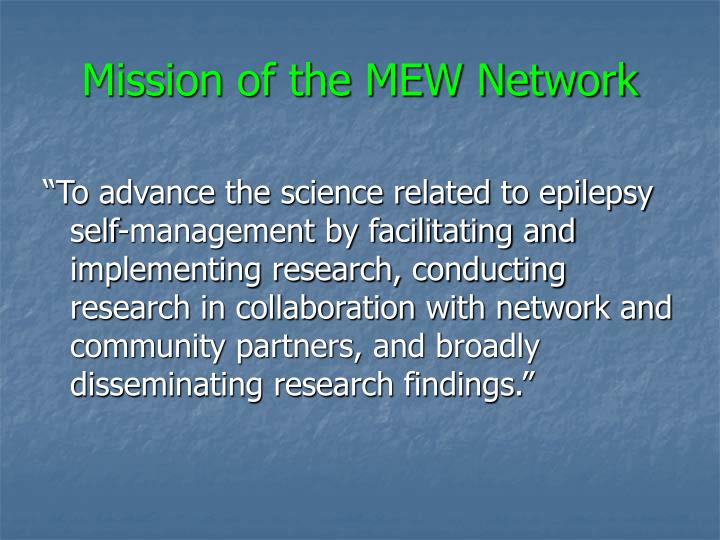What might be the primary area of focus for the MEW Network based on the mission statement? The primary focus of the MEW Network, as indicated by the mission statement in the image, is to advance the science related to epilepsy self-management. This is achieved through facilitating and implementing research, conducting it in collaboration with network and community partners, and by disseminating research findings widely. The emphasis is on scientific advancement in self-managing epilepsy, which likely encompasses improving the lives of individuals with epilepsy through research-driven knowledge, tools, and practices. 